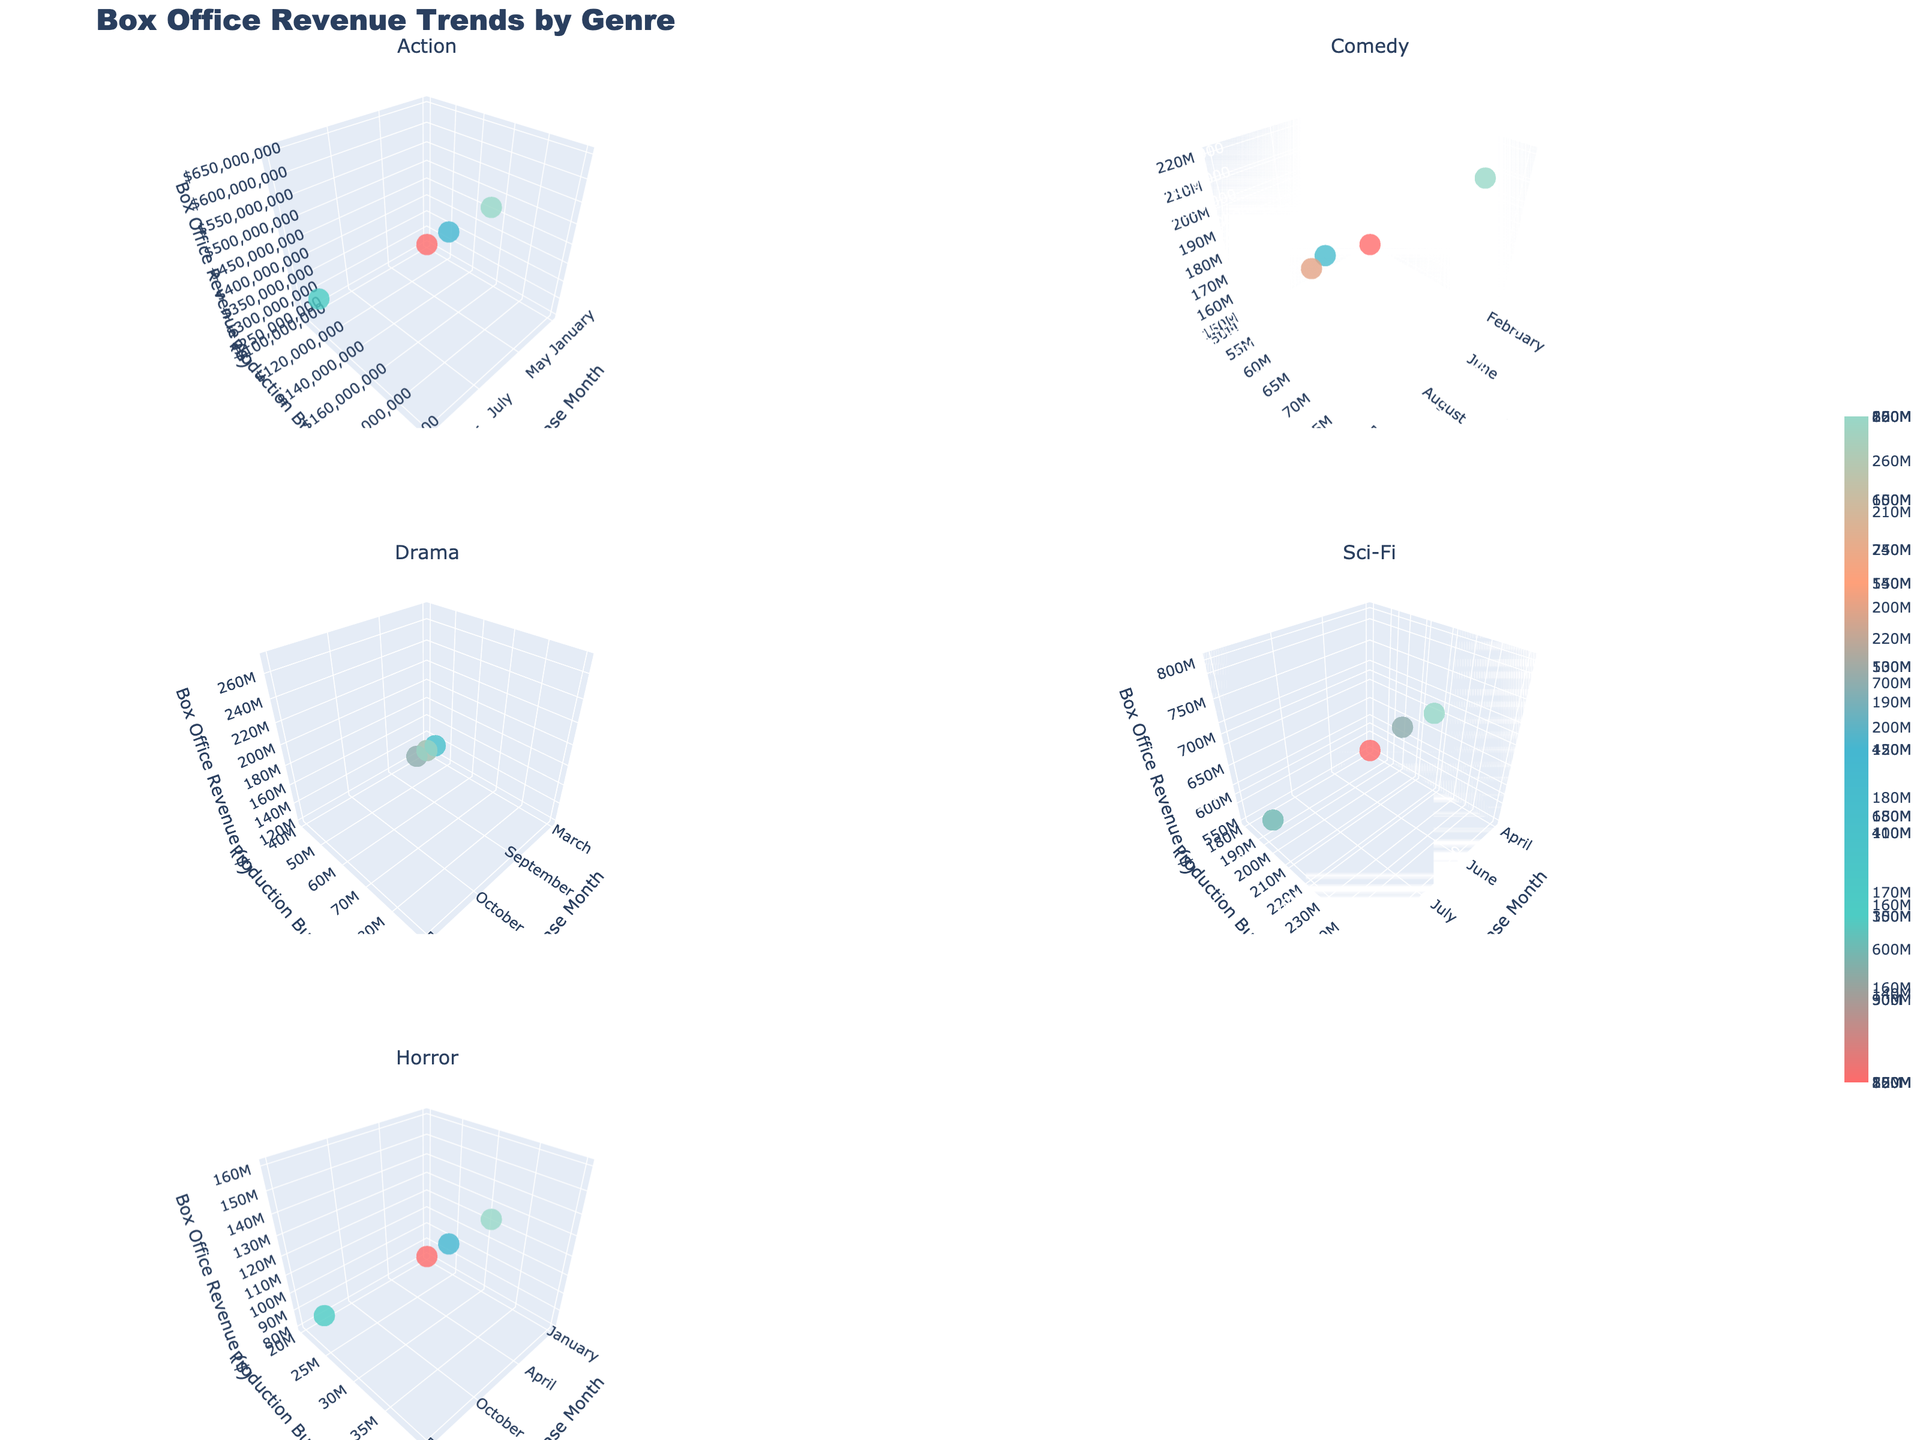What is the title of the figure? The title is usually placed at the top center of the figure. In this case, it is clearly stated as 'Box Office Revenue Trends by Genre'.
Answer: Box Office Revenue Trends by Genre Which genre appears in the first subplot (top-left)? By examining the subplot titles, the genre in the first (top-left) subplot can be identified as 'Action.' It's listed among other genres in the subplot titles.
Answer: Action How does the box office revenue trend for Action movies vary with increasing production budgets? The 3D plot for Action movies shows that as the production budget increases, the box office revenue also tends to increase. The markers rise higher on the z-axis as they move right along the y-axis.
Answer: Increases with budget Which genre has the highest box office revenue and in which months? By comparing the highest points in each subplot, Sci-Fi has the highest box office revenue, especially in June and July. These points are at the maximum z-axis value for Sci-Fi.
Answer: Sci-Fi, June and July Between Comedy and Drama genres, which has a higher average box office revenue? Calculate the average for each genre by summing their box office revenues and dividing by the number of data points. Comedy: (150+220+180+200)/4 = 187.5; Drama: (120+180+210+270)/4 = 195. Drama has a higher average.
Answer: Drama For which genre does the box office revenue show the most consistency across different release months and production budgets? Notice the spread of markers in each subplot. The genre with the least spread and most consistent z-values indicates consistency. Looking at the spread, Horror shows more consistency in revenue regardless of release month or budget.
Answer: Horror What's the range of box office revenue values for Sci-Fi movies? Find the minimum and maximum box office revenue values in the Sci-Fi subplot. Min is $550 million and max is $800 million.
Answer: $550 million to $800 million Do movies with lower production budgets always result in lower box office revenues across all genres? By examining all subplots, it's visible that this isn't always the case. For example, Horror movies with lower budgets still have significant box office revenues, disproving the statement.
Answer: No Which genre has the box office revenue closest to $350 million for the month of November? Focus on the data points in November across all genres and identify the closest to $350 million. The point in Action subplot (November, $350 million) matches exactly.
Answer: Action What's the general trend for box office revenue in the Drama genre with respect to release months? Observe the Drama subplot to see how box office revenue varies across months. Dramatically, Drama movies show increasing revenues as it gets closer to December.
Answer: Increases near December 